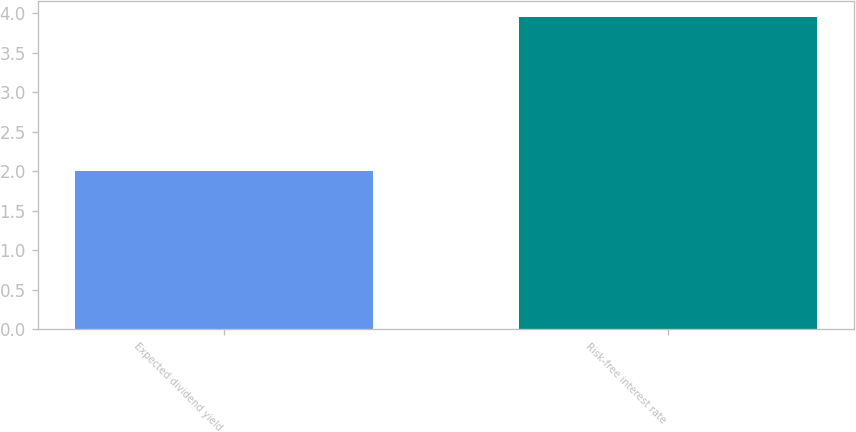<chart> <loc_0><loc_0><loc_500><loc_500><bar_chart><fcel>Expected dividend yield<fcel>Risk-free interest rate<nl><fcel>2<fcel>3.95<nl></chart> 